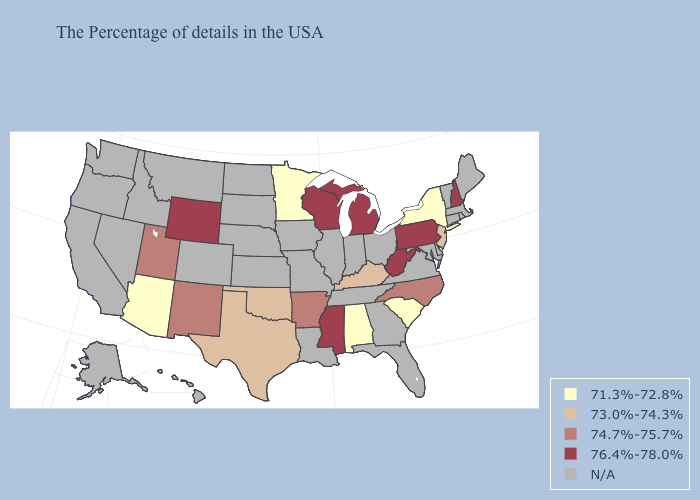What is the lowest value in the MidWest?
Quick response, please. 71.3%-72.8%. Among the states that border Delaware , does New Jersey have the highest value?
Write a very short answer. No. Does Kentucky have the highest value in the USA?
Keep it brief. No. Name the states that have a value in the range 71.3%-72.8%?
Keep it brief. New York, South Carolina, Alabama, Minnesota, Arizona. What is the highest value in the MidWest ?
Quick response, please. 76.4%-78.0%. What is the highest value in states that border Pennsylvania?
Keep it brief. 76.4%-78.0%. What is the lowest value in the USA?
Short answer required. 71.3%-72.8%. Is the legend a continuous bar?
Quick response, please. No. Among the states that border Montana , which have the highest value?
Short answer required. Wyoming. Name the states that have a value in the range 73.0%-74.3%?
Write a very short answer. New Jersey, Kentucky, Oklahoma, Texas. What is the value of New Mexico?
Keep it brief. 74.7%-75.7%. Which states have the highest value in the USA?
Give a very brief answer. New Hampshire, Pennsylvania, West Virginia, Michigan, Wisconsin, Mississippi, Wyoming. What is the lowest value in states that border Vermont?
Answer briefly. 71.3%-72.8%. What is the lowest value in the South?
Answer briefly. 71.3%-72.8%. 